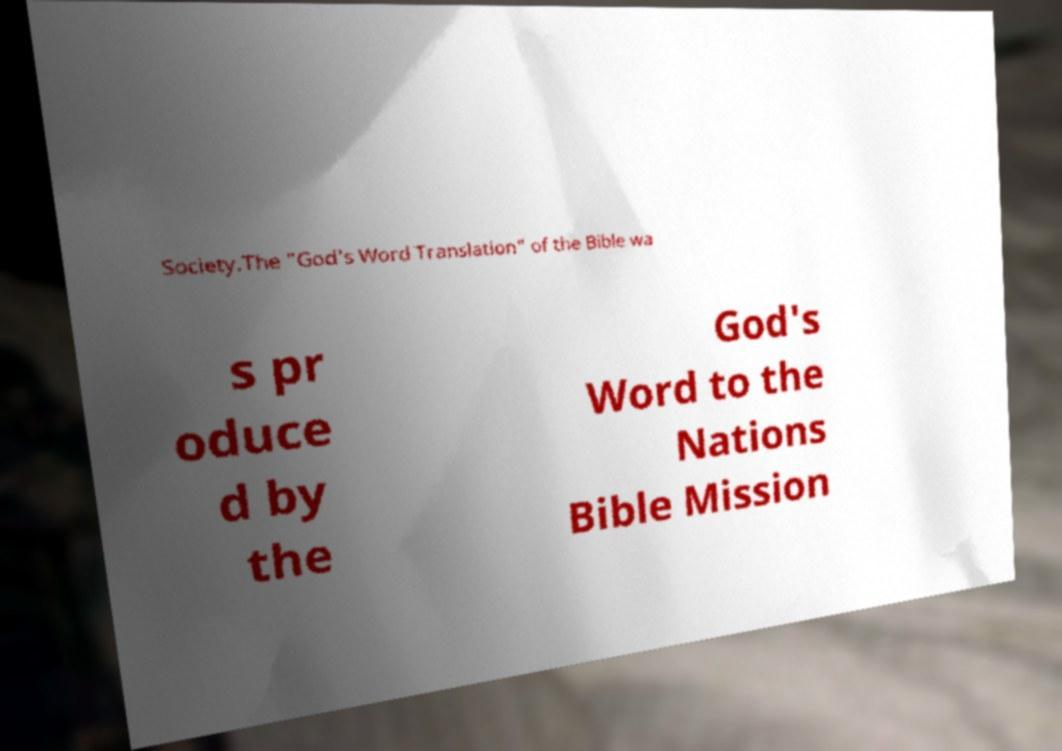Can you read and provide the text displayed in the image?This photo seems to have some interesting text. Can you extract and type it out for me? Society.The "God's Word Translation" of the Bible wa s pr oduce d by the God's Word to the Nations Bible Mission 